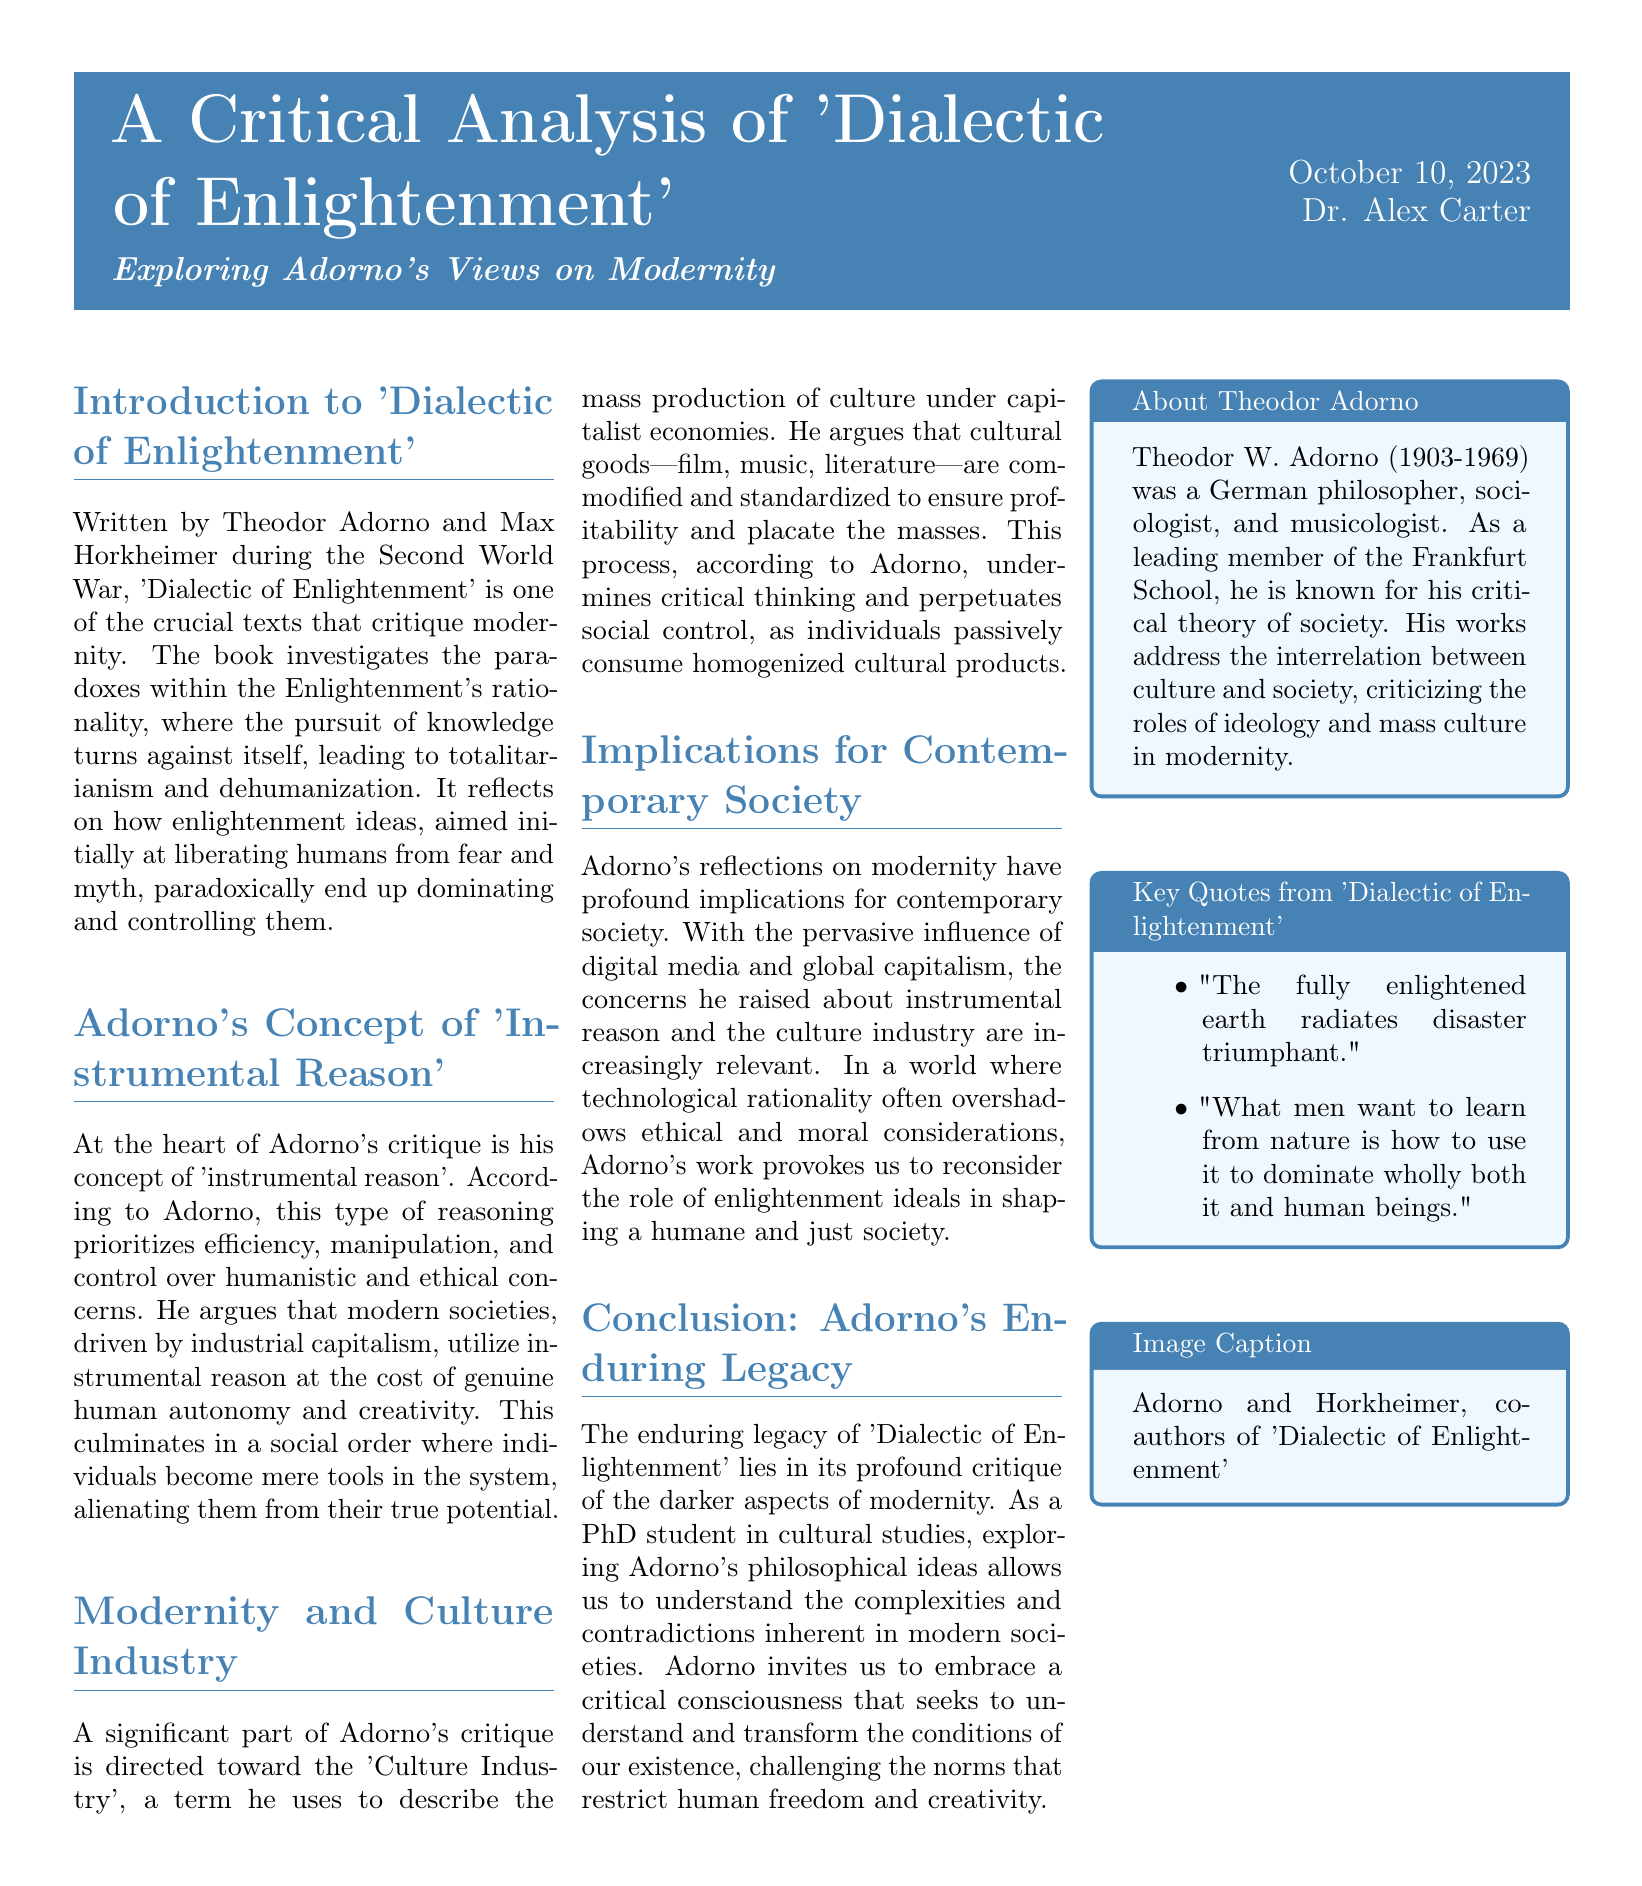What is the title of the document? The title is prominently displayed at the top of the document and identifies the main subject.
Answer: A Critical Analysis of 'Dialectic of Enlightenment' Who are the authors of 'Dialectic of Enlightenment'? The authors are mentioned in the introduction, highlighting their contribution to the text.
Answer: Theodor Adorno and Max Horkheimer What concept does Adorno critique in the document? The document elaborates on Adorno's critique of a specific type of reasoning central to his argument.
Answer: Instrumental reason What term does Adorno use to describe mass-produced culture? This term is introduced in the section discussing culture and its commodification under capitalism.
Answer: Culture Industry What date was the document published? The date of publication is provided in the header section of the document.
Answer: October 10, 2023 What is one implication of Adorno's views for contemporary society? This is addressed in a section discussing the relevance of Adorno's critiques today.
Answer: Technological rationality overshadows ethical considerations Which philosophical school was Adorno affiliated with? Adorno's association with a specific philosophical movement is mentioned in the 'About Theodor Adorno' section.
Answer: Frankfurt School How many key quotes are listed in the document? The number of items in the list of key quotes reveals the focus on significant phrases in Adorno's work.
Answer: Two 